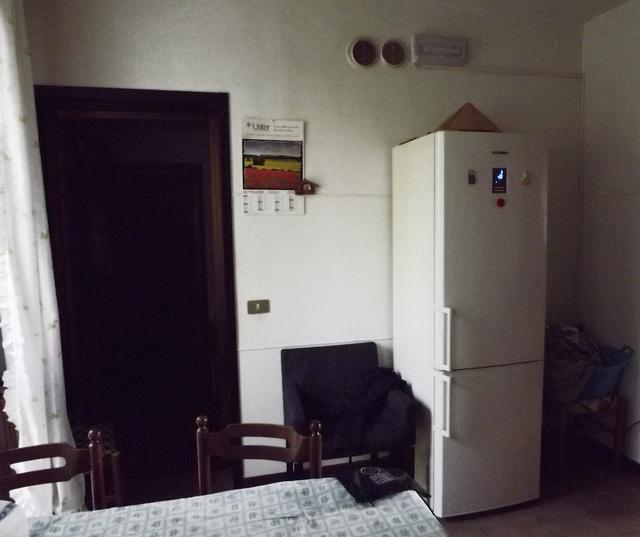Is there a hamper?
Concise answer only. Yes. Is there a calendar on the wall?
Give a very brief answer. Yes. Where is the clock?
Quick response, please. On wall. What color are the chairs?
Be succinct. Brown. 